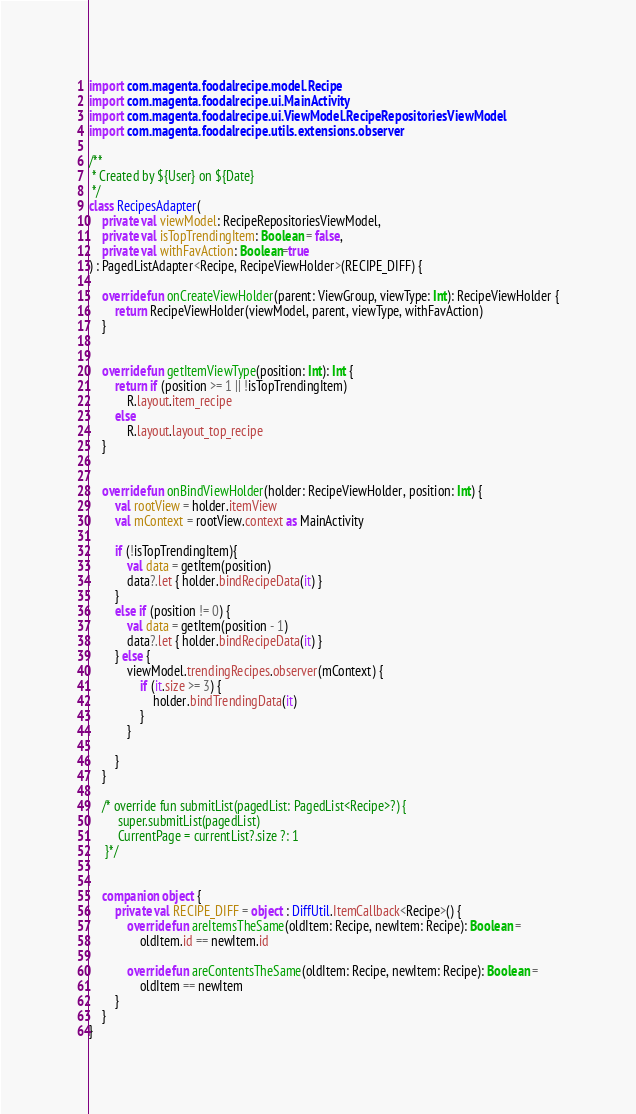Convert code to text. <code><loc_0><loc_0><loc_500><loc_500><_Kotlin_>import com.magenta.foodalrecipe.model.Recipe
import com.magenta.foodalrecipe.ui.MainActivity
import com.magenta.foodalrecipe.ui.ViewModel.RecipeRepositoriesViewModel
import com.magenta.foodalrecipe.utils.extensions.observer

/**
 * Created by ${User} on ${Date}
 */
class RecipesAdapter(
    private val viewModel: RecipeRepositoriesViewModel,
    private val isTopTrendingItem: Boolean = false,
    private val withFavAction: Boolean=true
) : PagedListAdapter<Recipe, RecipeViewHolder>(RECIPE_DIFF) {

    override fun onCreateViewHolder(parent: ViewGroup, viewType: Int): RecipeViewHolder {
        return RecipeViewHolder(viewModel, parent, viewType, withFavAction)
    }


    override fun getItemViewType(position: Int): Int {
        return if (position >= 1 || !isTopTrendingItem)
            R.layout.item_recipe
        else
            R.layout.layout_top_recipe
    }


    override fun onBindViewHolder(holder: RecipeViewHolder, position: Int) {
        val rootView = holder.itemView
        val mContext = rootView.context as MainActivity

        if (!isTopTrendingItem){
            val data = getItem(position)
            data?.let { holder.bindRecipeData(it) }
        }
        else if (position != 0) {
            val data = getItem(position - 1)
            data?.let { holder.bindRecipeData(it) }
        } else {
            viewModel.trendingRecipes.observer(mContext) {
                if (it.size >= 3) {
                    holder.bindTrendingData(it)
                }
            }

        }
    }

    /* override fun submitList(pagedList: PagedList<Recipe>?) {
         super.submitList(pagedList)
         CurrentPage = currentList?.size ?: 1
     }*/


    companion object {
        private val RECIPE_DIFF = object : DiffUtil.ItemCallback<Recipe>() {
            override fun areItemsTheSame(oldItem: Recipe, newItem: Recipe): Boolean =
                oldItem.id == newItem.id

            override fun areContentsTheSame(oldItem: Recipe, newItem: Recipe): Boolean =
                oldItem == newItem
        }
    }
}</code> 